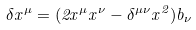Convert formula to latex. <formula><loc_0><loc_0><loc_500><loc_500>\delta x ^ { \mu } = ( 2 x ^ { \mu } x ^ { \nu } - \delta ^ { \mu \nu } x ^ { 2 } ) b _ { \nu }</formula> 